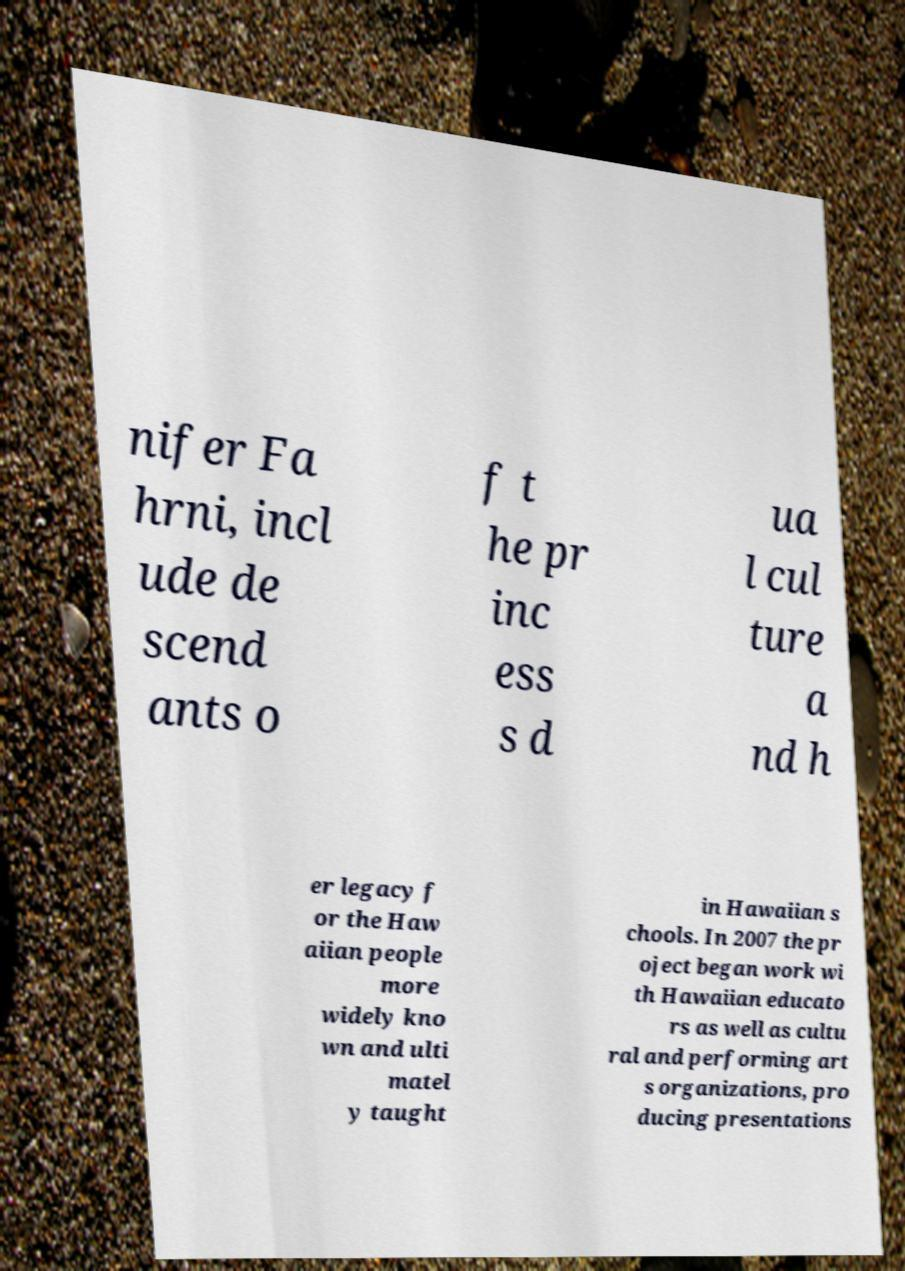Can you read and provide the text displayed in the image?This photo seems to have some interesting text. Can you extract and type it out for me? nifer Fa hrni, incl ude de scend ants o f t he pr inc ess s d ua l cul ture a nd h er legacy f or the Haw aiian people more widely kno wn and ulti matel y taught in Hawaiian s chools. In 2007 the pr oject began work wi th Hawaiian educato rs as well as cultu ral and performing art s organizations, pro ducing presentations 